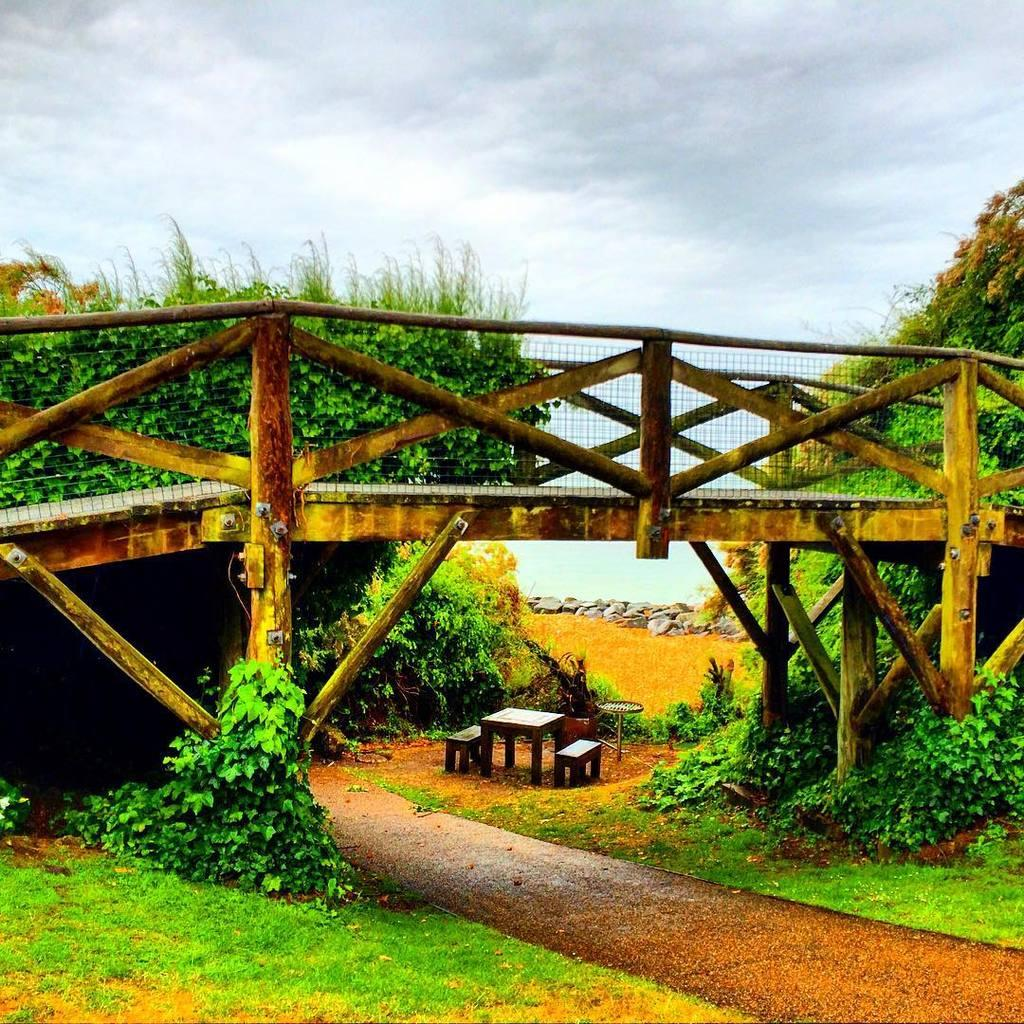What is the main feature of the image? There is an empty road in the image. What type of vegetation can be seen in the image? There are plants, grass, and trees in the image. What type of structure is present in the image? There is a bridge in the image. What type of bun is being used for a science experiment in the image? There is no bun or science experiment present in the image. Can you tell me how many people are swimming in the image? There is no swimming or people visible in the image. 